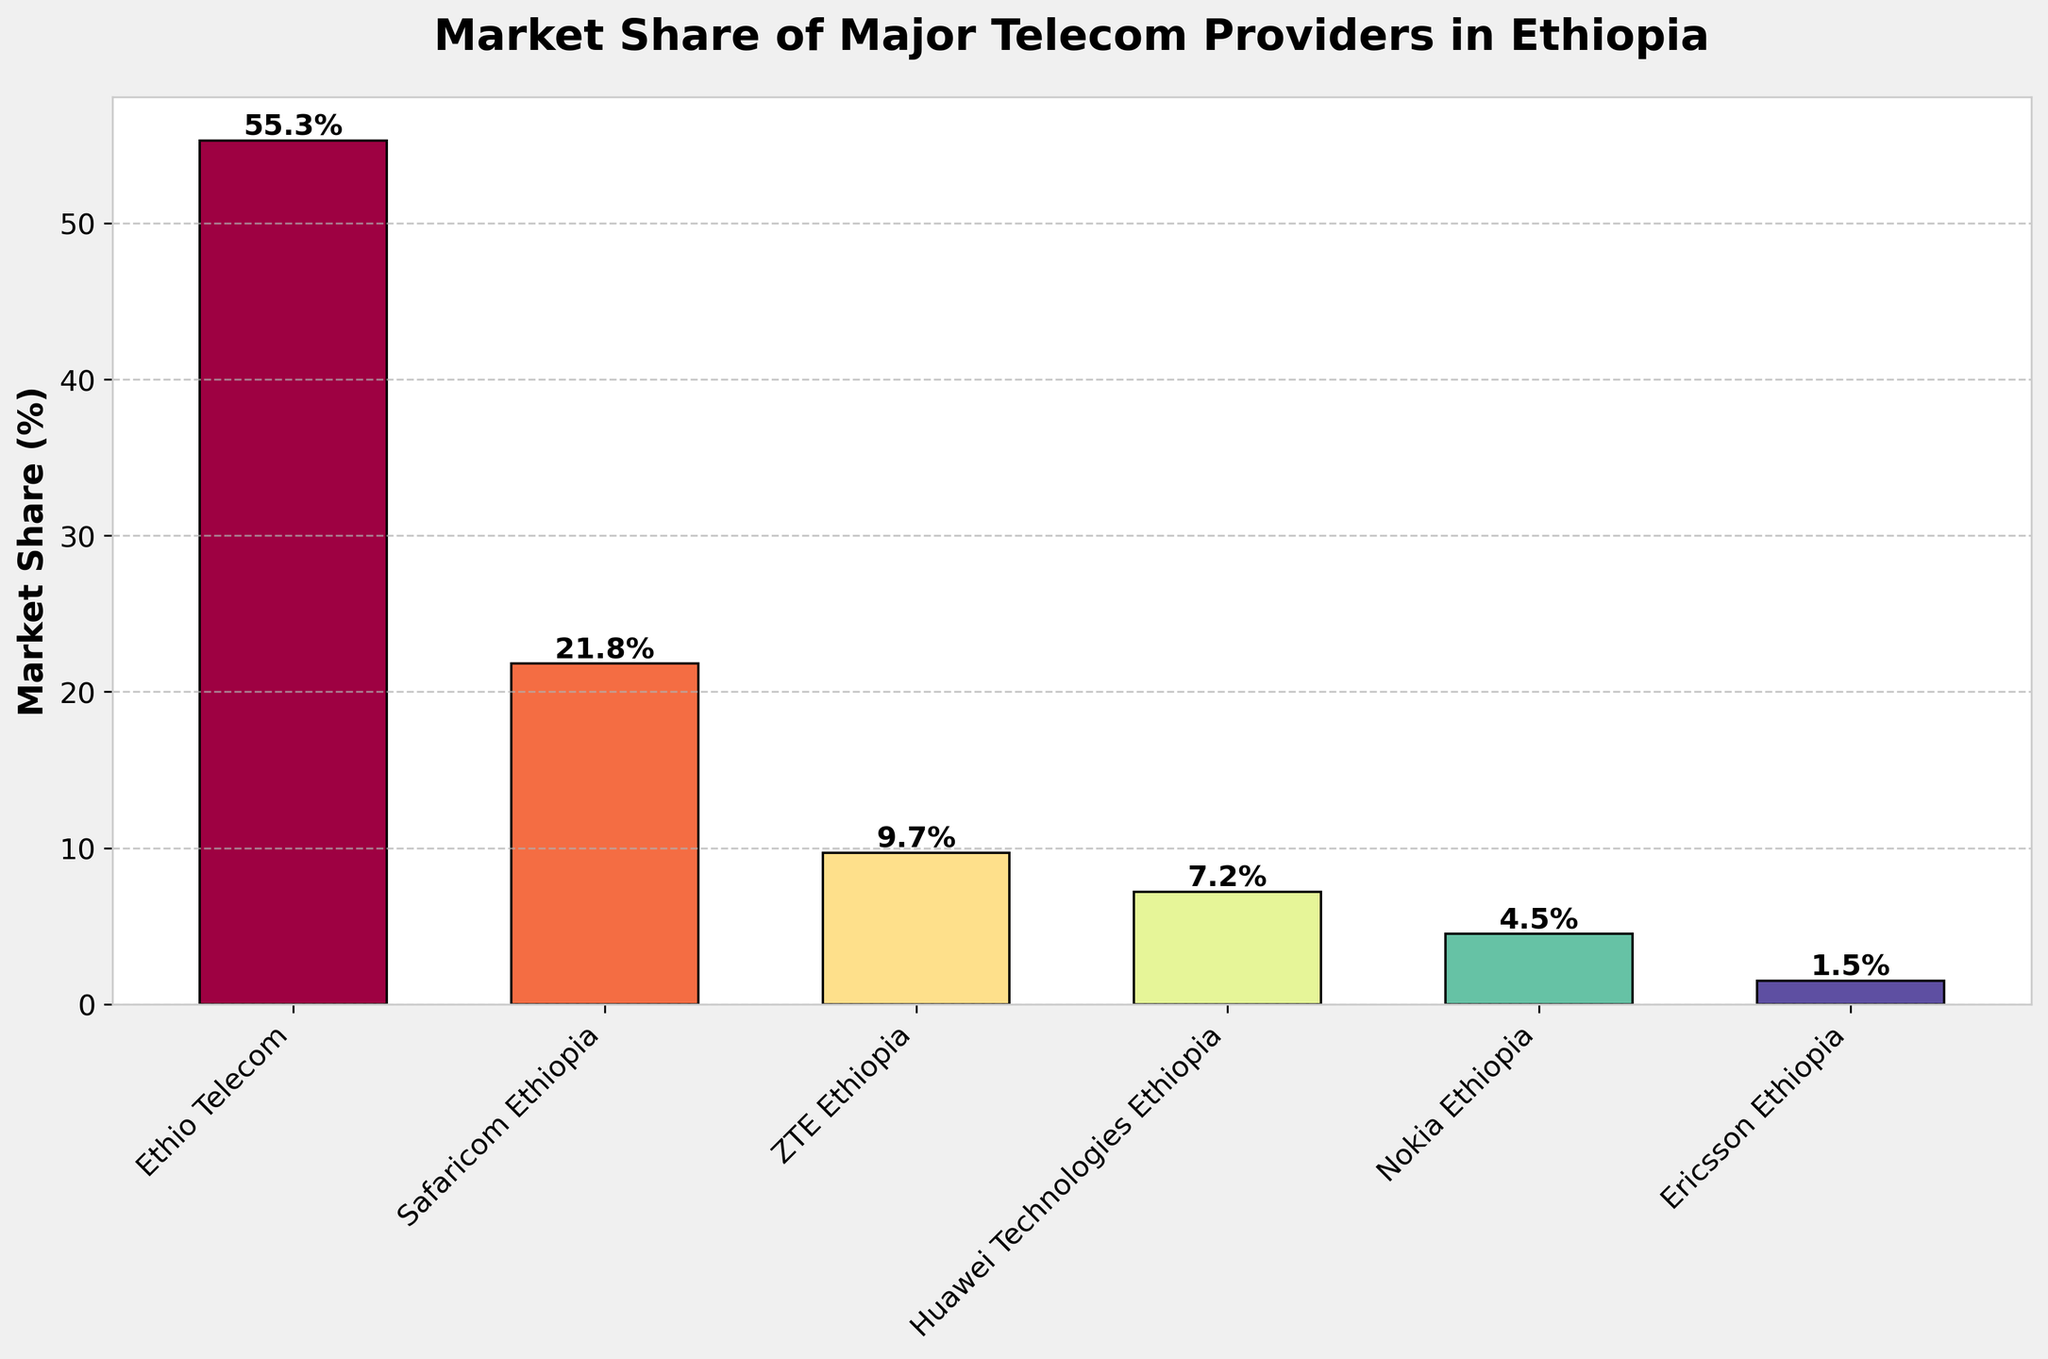What's the market share of the telecom provider with the highest market share? Identify the bar that represents the highest market share. Ethio Telecom's bar is the tallest with a market share of 55.3%.
Answer: 55.3% Which telecom provider has a market share closest to 10%? Look at the bar heights to find the provider with a market share closest to 10%. ZTE Ethiopia has a market share of 9.7%, which is closest to 10%.
Answer: ZTE Ethiopia Which telecom providers have a combined market share of more than 30%? Check the bars and sum the market shares of the providers to find combinations greater than 30%. Ethio Telecom (55.3%) alone exceeds 30%. Safaricom Ethiopia (21.8%) and ZTE Ethiopia (9.7%) combined give a total of 31.5%, also exceeding 30%.
Answer: Ethio Telecom, Safaricom Ethiopia, ZTE Ethiopia How much more market share does Ethio Telecom have compared to Safaricom Ethiopia? Subtract the market share of Safaricom Ethiopia from Ethio Telecom's market share: 55.3% - 21.8% = 33.5%.
Answer: 33.5% Which telecom provider is represented by the bar with the second smallest height? Find the second shortest bar in the chart. Ericsson Ethiopia (1.5%) is the shortest, so the second shortest is Nokia Ethiopia at 4.5%.
Answer: Nokia Ethiopia What percentage of market share is covered by providers with more than 5% market share each? Sum up the percentages of providers with market shares greater than 5%: Ethio Telecom (55.3%), Safaricom Ethiopia (21.8%), ZTE Ethiopia (9.7%), and Huawei Technologies Ethiopia (7.2%): 55.3 + 21.8 + 9.7 + 7.2 = 94%.
Answer: 94% Compare the combined market share of Huawei Technologies Ethiopia and Nokia Ethiopia to Safaricom Ethiopia. Which is higher? Sum the market shares of Huawei Technologies Ethiopia (7.2%) and Nokia Ethiopia (4.5%), then compare to Safaricom Ethiopia (21.8%): 7.2% + 4.5% = 11.7%, which is less than 21.8%.
Answer: Safaricom Ethiopia Which telecom provider has a blue bar? By examining the colors used in the bar chart, identify the provider associated with the blue bar. The blue bar corresponds to ZTE Ethiopia.
Answer: ZTE Ethiopia 